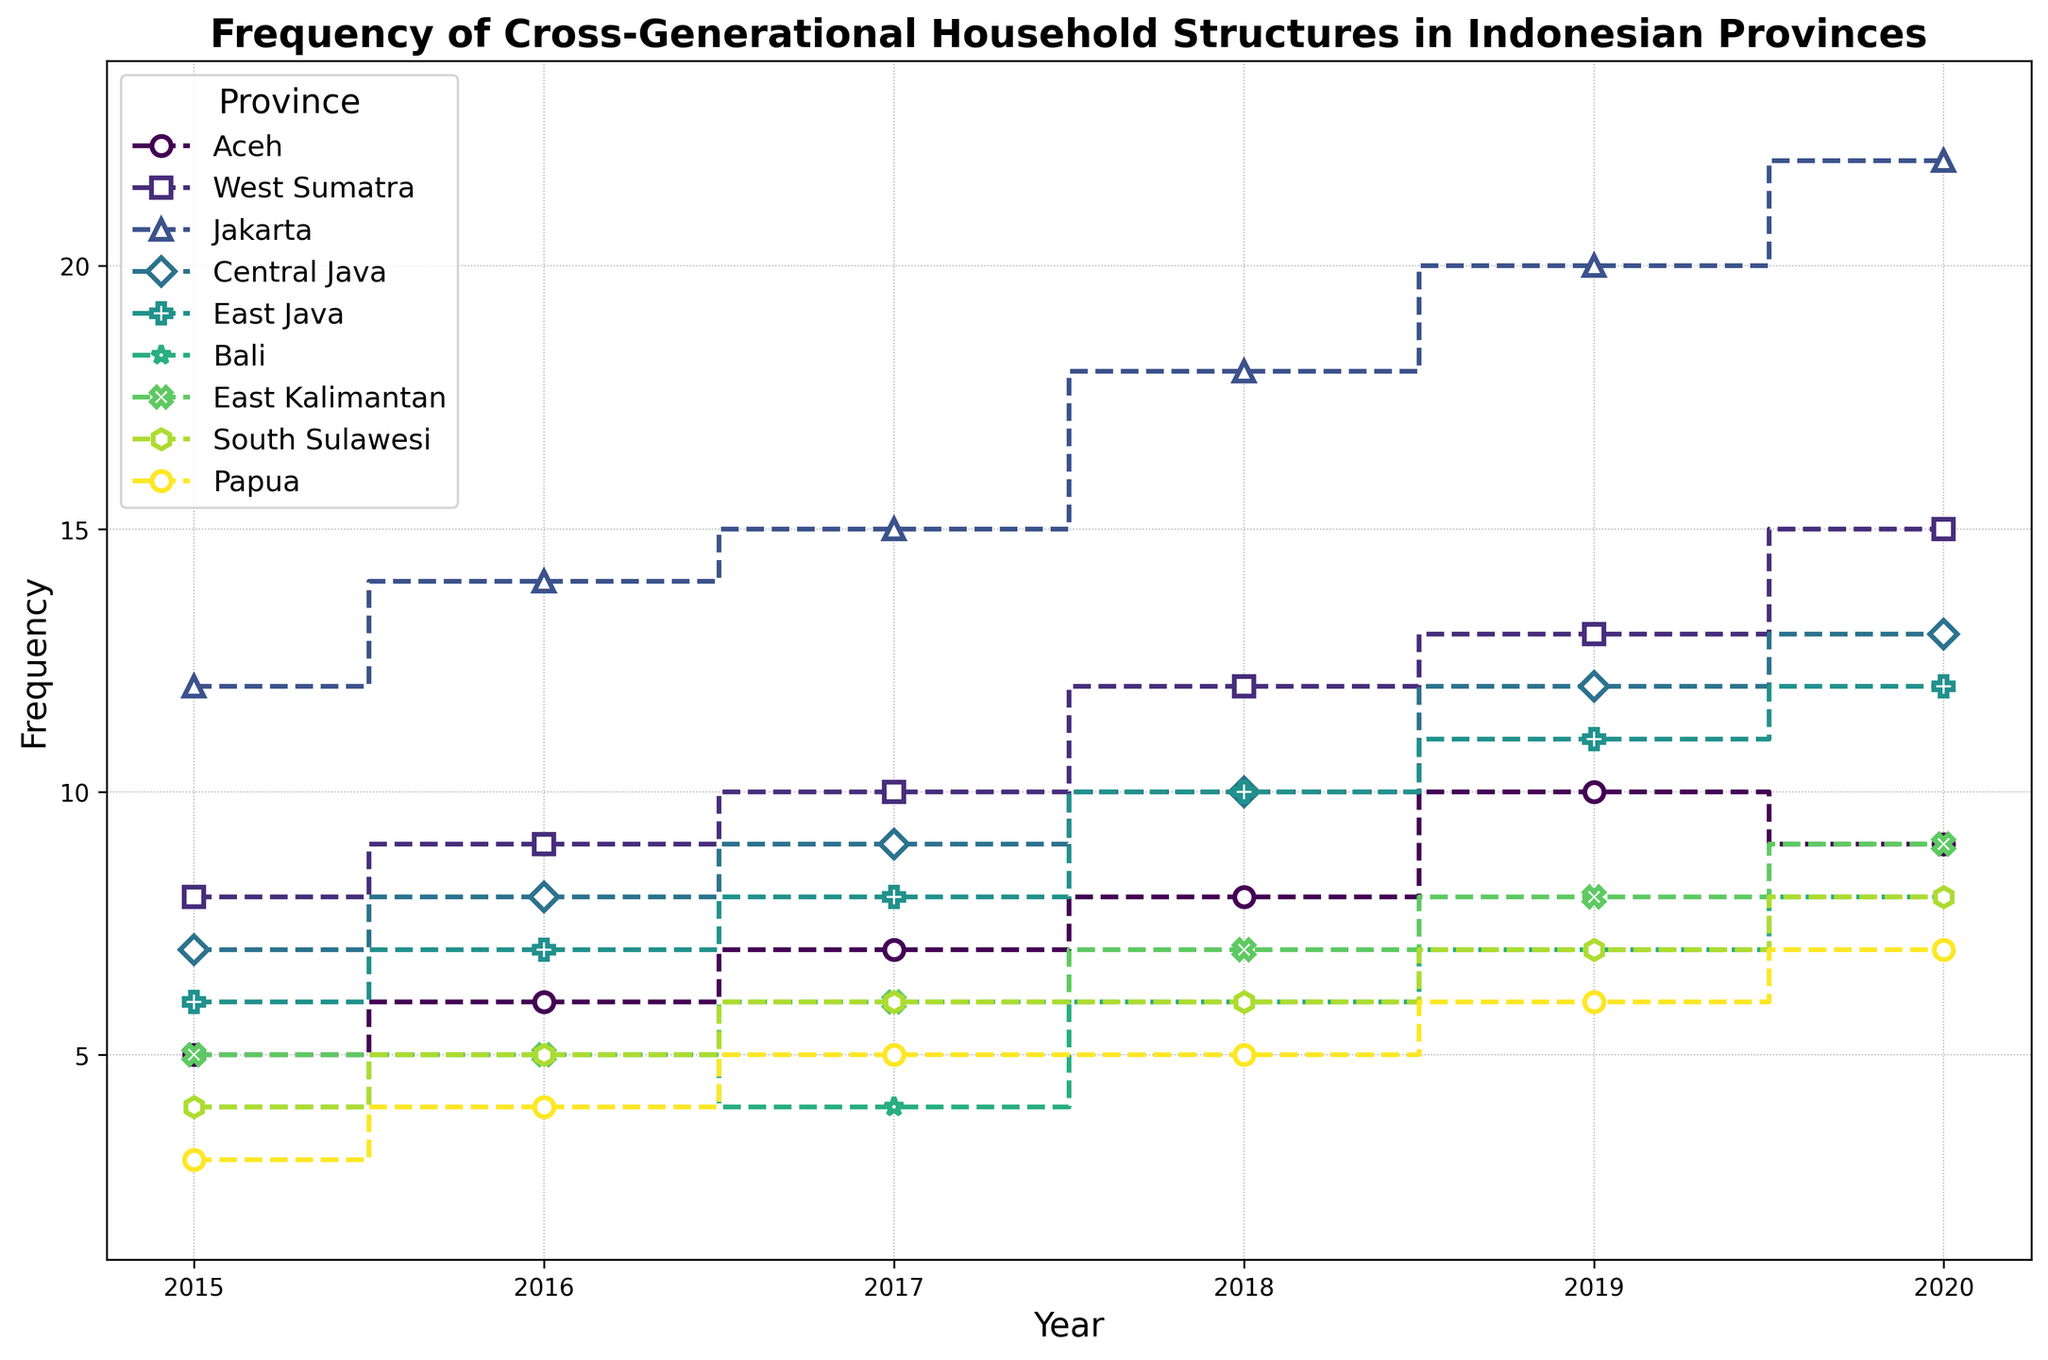Which province has the highest frequency of cross-generational household structures in 2020? Refer to the graph and look for the highest point on the y-axis for the year 2020. The province with the highest value is Jakarta.
Answer: Jakarta How did the frequency of cross-generational households in East Kalimantan change from 2015 to 2020? Track the line for East Kalimantan on the graph from 2015 to 2020, noting the changes in y-axis values each year. The values increase from 5 to 9, showing an upward trend.
Answer: Increased Which province has a higher frequency of cross-generational households in 2018: Central Java or Bali? Compare the data points for 2018 of Central Java and Bali on the y-axis. Central Java has a value of 10, while Bali has a value of 6.
Answer: Central Java What is the average frequency of cross-generational households in West Sumatra from 2015 to 2020? Sum the values for each year from 2015 to 2020 and then divide by the number of years: (8+9+10+12+13+15)/6 = 67/6 ≈ 11.17.
Answer: 11.17 Between which years did Jakarta experience the largest increase in frequency? Compare the differences in y-axis values for each consecutive year for Jakarta. The largest increase is between 2018 (18) and 2019 (20).
Answer: 2018 and 2019 Which province shows a decreasing trend in the frequency of cross-generational households from 2019 to 2020? Look for provinces where the line descends between 2019 and 2020. Aceh shows a decrease from 10 to 9.
Answer: Aceh How many provinces had a frequency of 7 or more in 2019? Count the number of provinces with data points at 7 or above on the y-axis for 2019. There are Aceh (10), West Sumatra (13), Jakarta (20), Central Java (12), East Java (11), and Bali (7), totaling 6.
Answer: 6 What is the total frequency of cross-generational households in Bali across all years presented? Sum the y-axis values for Bali from 2015 to 2020: 4 + 5 + 4 + 6 + 7 + 8 = 34.
Answer: 34 Which color represents West Sumatra? Identify the line that corresponds to West Sumatra and note the color used by looking at the legend. The color for West Sumatra is a specific shade in the colormap, typically identified by verifying the label name and line color match in the legend.
Answer: Specific shade (from the colormap based on the legend) 